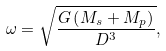<formula> <loc_0><loc_0><loc_500><loc_500>\omega = \sqrt { \frac { G \left ( M _ { s } + M _ { p } \right ) } { D ^ { 3 } } } ,</formula> 